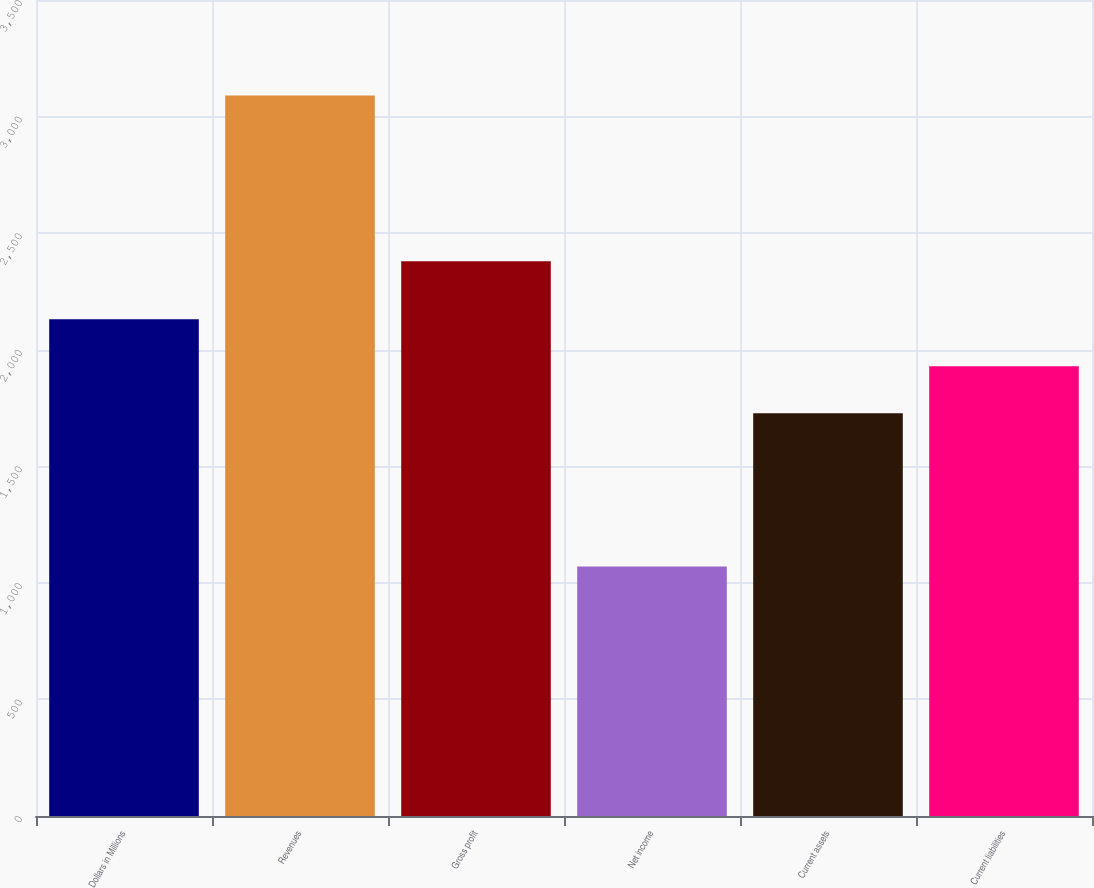<chart> <loc_0><loc_0><loc_500><loc_500><bar_chart><fcel>Dollars in Millions<fcel>Revenues<fcel>Gross profit<fcel>Net income<fcel>Current assets<fcel>Current liabilities<nl><fcel>2131<fcel>3090<fcel>2379<fcel>1070<fcel>1727<fcel>1929<nl></chart> 